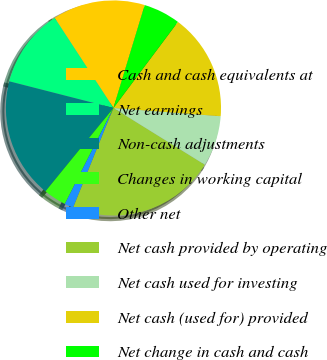<chart> <loc_0><loc_0><loc_500><loc_500><pie_chart><fcel>Cash and cash equivalents at<fcel>Net earnings<fcel>Non-cash adjustments<fcel>Changes in working capital<fcel>Other net<fcel>Net cash provided by operating<fcel>Net cash used for investing<fcel>Net cash (used for) provided<fcel>Net change in cash and cash<nl><fcel>13.9%<fcel>11.81%<fcel>18.09%<fcel>3.44%<fcel>1.34%<fcel>22.27%<fcel>7.62%<fcel>15.99%<fcel>5.53%<nl></chart> 